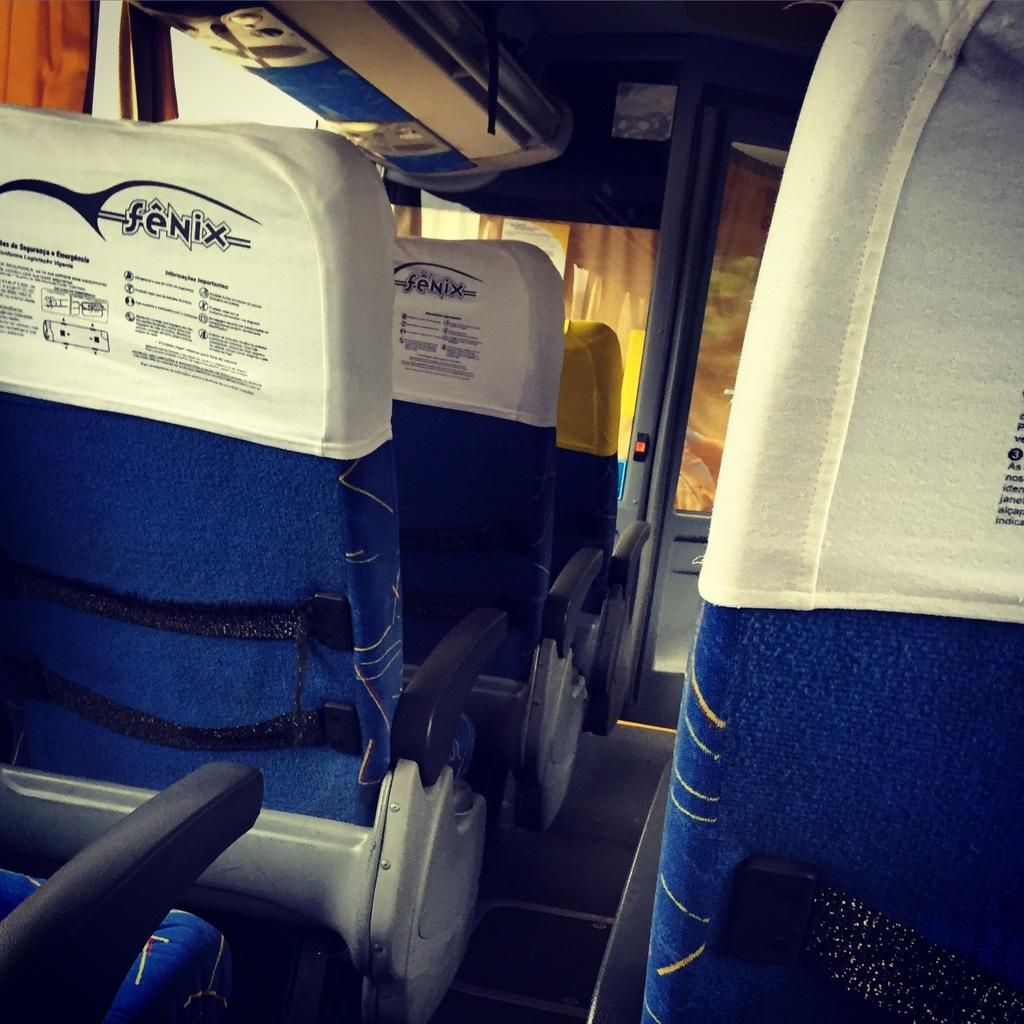What can be seen in the image that is not occupied? There are empty seats in the image. What is written on the seats or nearby? There is text written on the seats or nearby. What type of window treatment is present in the image? There are curtains in the image. What architectural feature is present in the image? There is a door in the image. What allows natural light to enter the space? There are windows in the image. What type of room or area is depicted in the image? There is a cabin at the top of the image. What type of cake is being served in the image? There is no cake present in the image. How does the ship navigate in the image? There is no ship present in the image. 